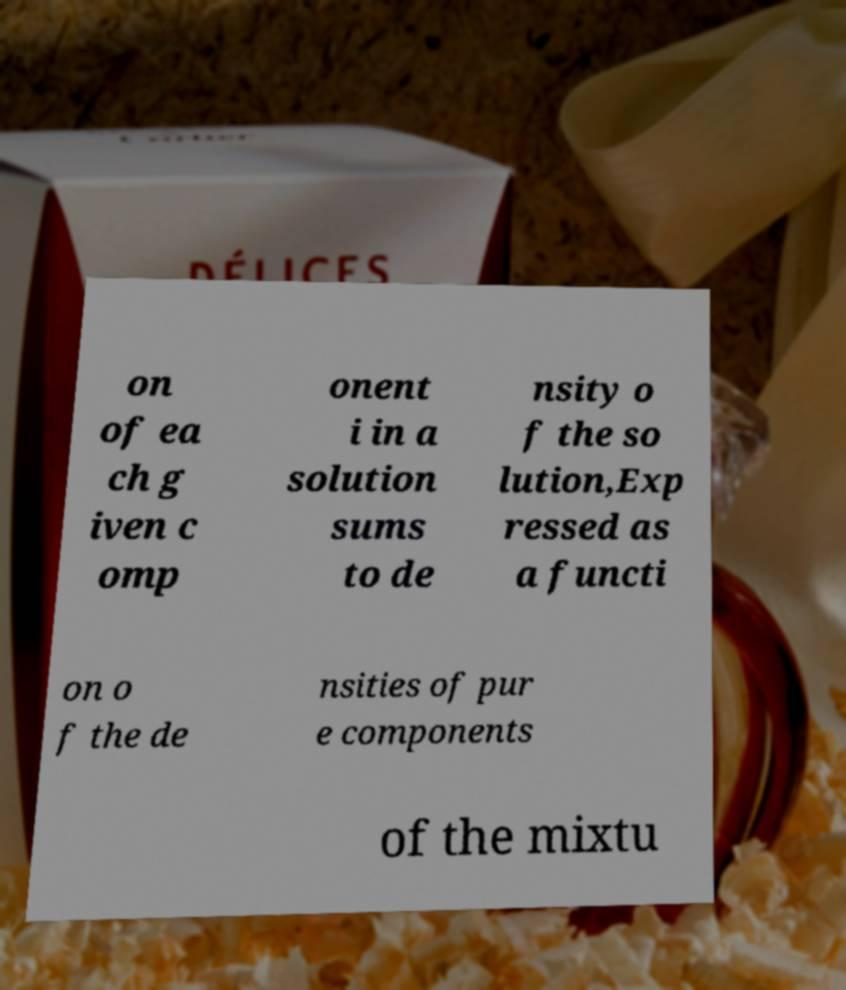There's text embedded in this image that I need extracted. Can you transcribe it verbatim? on of ea ch g iven c omp onent i in a solution sums to de nsity o f the so lution,Exp ressed as a functi on o f the de nsities of pur e components of the mixtu 